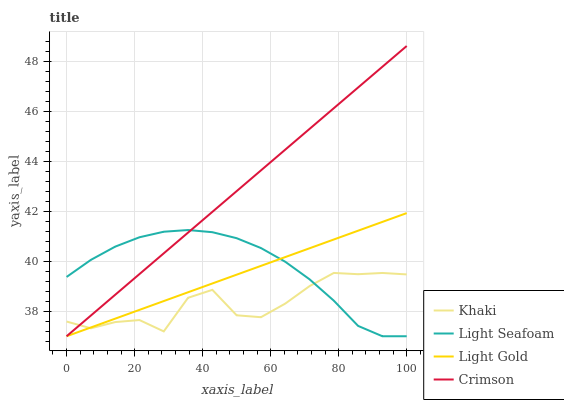Does Khaki have the minimum area under the curve?
Answer yes or no. Yes. Does Crimson have the maximum area under the curve?
Answer yes or no. Yes. Does Light Gold have the minimum area under the curve?
Answer yes or no. No. Does Light Gold have the maximum area under the curve?
Answer yes or no. No. Is Light Gold the smoothest?
Answer yes or no. Yes. Is Khaki the roughest?
Answer yes or no. Yes. Is Khaki the smoothest?
Answer yes or no. No. Is Light Gold the roughest?
Answer yes or no. No. Does Khaki have the lowest value?
Answer yes or no. No. Does Crimson have the highest value?
Answer yes or no. Yes. Does Light Gold have the highest value?
Answer yes or no. No. 